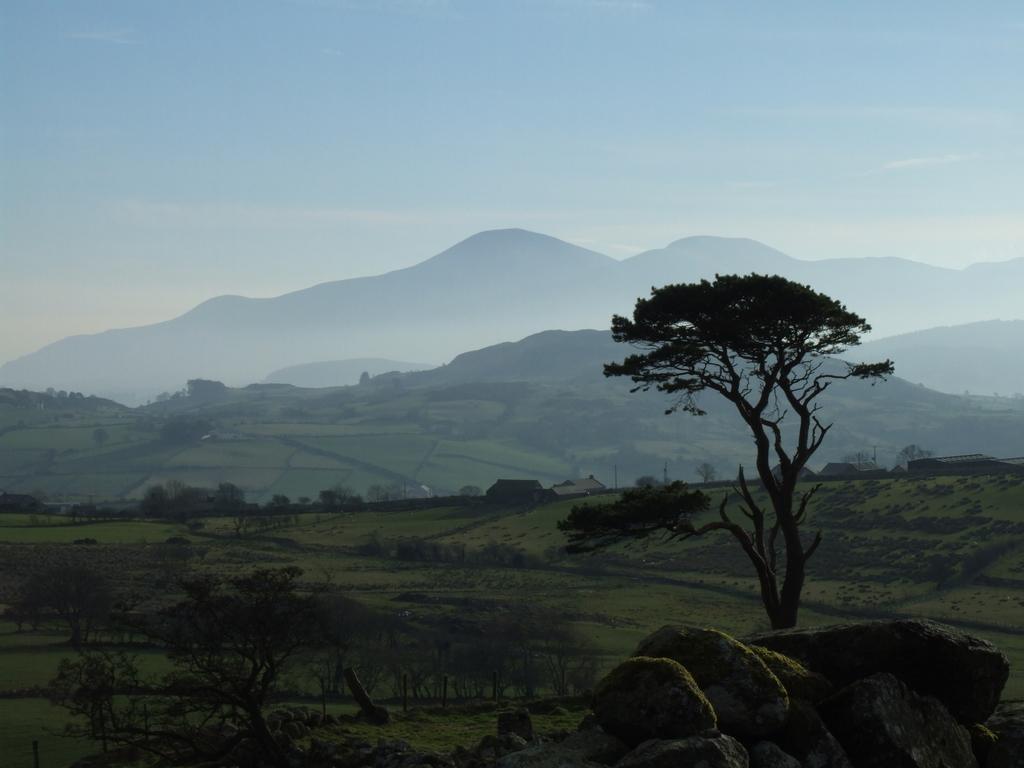Describe this image in one or two sentences. This picture is clicked outside. In the foreground we can see the green grass, trees and the rocks. In the background we can see the sky, hills, trees, houses and some other objects. 